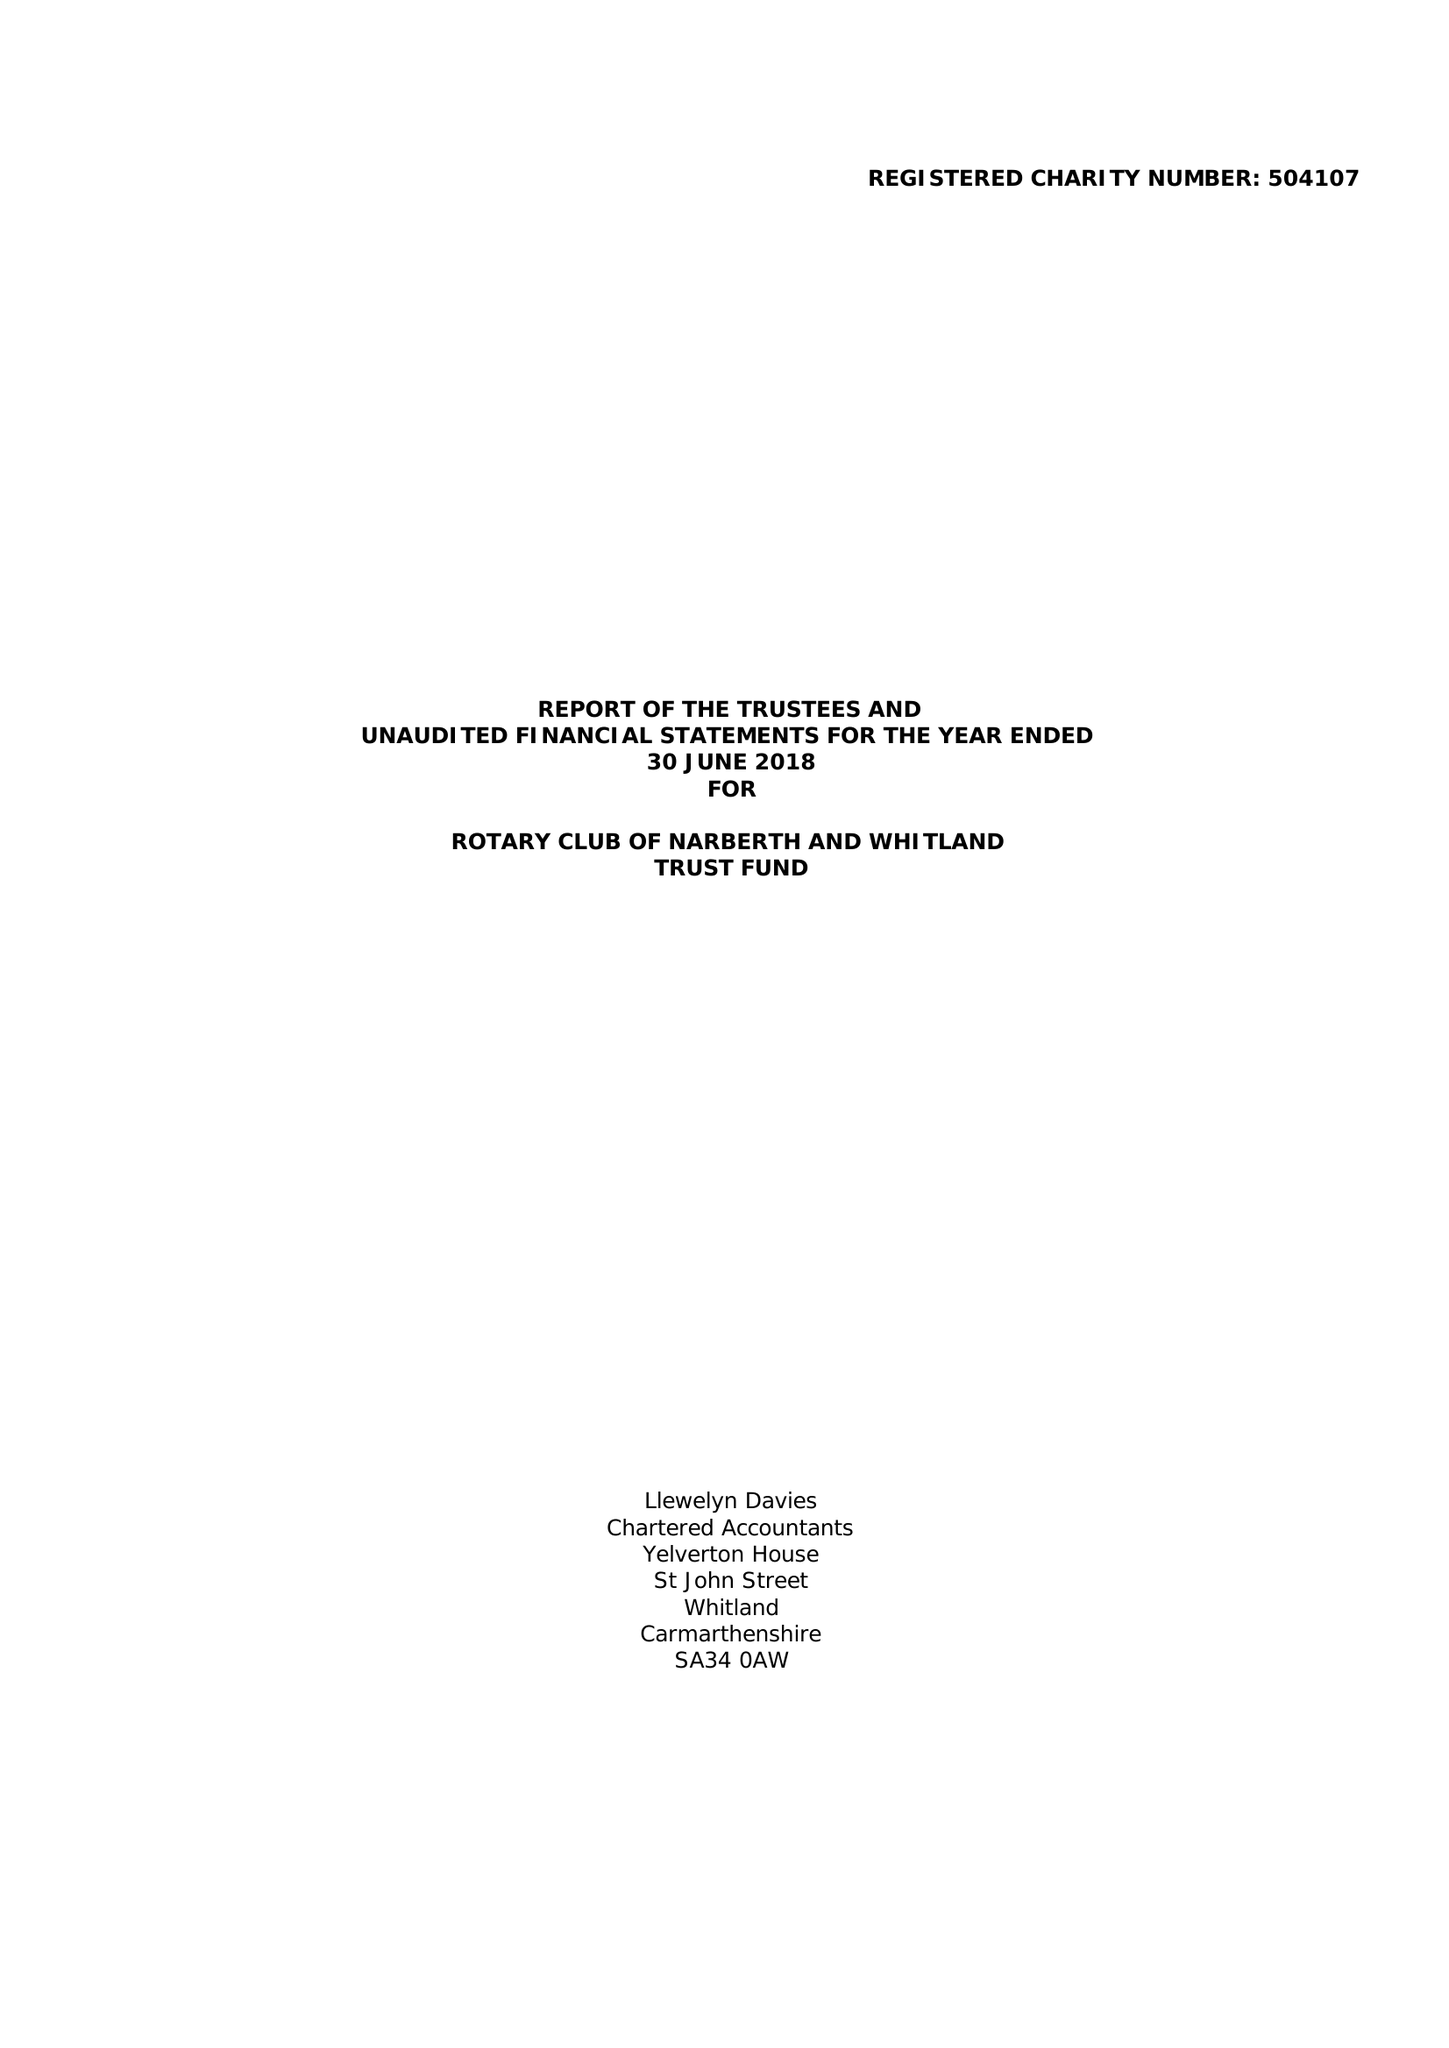What is the value for the spending_annually_in_british_pounds?
Answer the question using a single word or phrase. 26414.00 